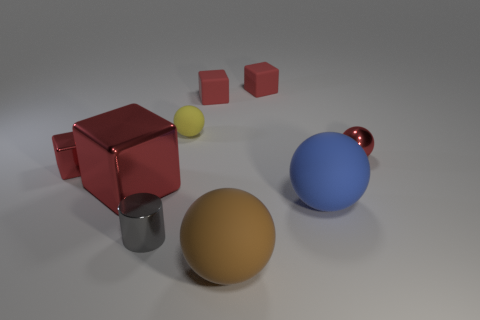How many red blocks must be subtracted to get 2 red blocks? 2 Subtract all tiny blocks. How many blocks are left? 1 Subtract all brown spheres. How many spheres are left? 3 Add 1 red matte blocks. How many objects exist? 10 Subtract 3 balls. How many balls are left? 1 Subtract 1 brown spheres. How many objects are left? 8 Subtract all cubes. How many objects are left? 5 Subtract all green cylinders. Subtract all green blocks. How many cylinders are left? 1 Subtract all brown blocks. How many gray spheres are left? 0 Subtract all small yellow rubber things. Subtract all large blue rubber spheres. How many objects are left? 7 